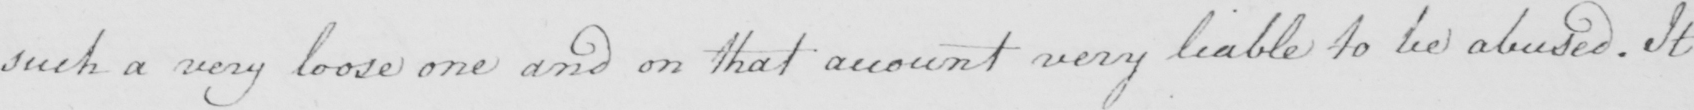Can you tell me what this handwritten text says? such a very loose one and on that account very liable to be abused . It 